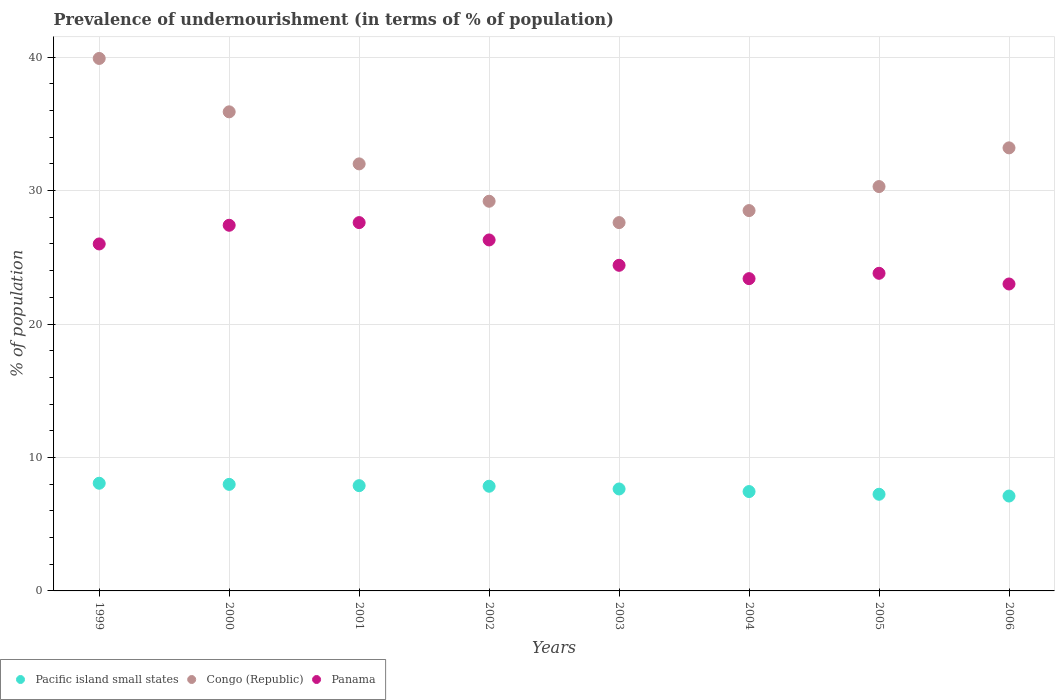How many different coloured dotlines are there?
Ensure brevity in your answer.  3. What is the percentage of undernourished population in Congo (Republic) in 2006?
Provide a short and direct response. 33.2. Across all years, what is the maximum percentage of undernourished population in Congo (Republic)?
Offer a terse response. 39.9. Across all years, what is the minimum percentage of undernourished population in Congo (Republic)?
Make the answer very short. 27.6. In which year was the percentage of undernourished population in Panama maximum?
Keep it short and to the point. 2001. What is the total percentage of undernourished population in Pacific island small states in the graph?
Keep it short and to the point. 61.22. What is the difference between the percentage of undernourished population in Panama in 2001 and that in 2002?
Keep it short and to the point. 1.3. What is the difference between the percentage of undernourished population in Congo (Republic) in 2003 and the percentage of undernourished population in Panama in 2005?
Offer a terse response. 3.8. What is the average percentage of undernourished population in Congo (Republic) per year?
Give a very brief answer. 32.08. In the year 2004, what is the difference between the percentage of undernourished population in Pacific island small states and percentage of undernourished population in Panama?
Offer a terse response. -15.95. In how many years, is the percentage of undernourished population in Pacific island small states greater than 26 %?
Provide a short and direct response. 0. What is the ratio of the percentage of undernourished population in Panama in 1999 to that in 2006?
Give a very brief answer. 1.13. What is the difference between the highest and the second highest percentage of undernourished population in Panama?
Ensure brevity in your answer.  0.2. What is the difference between the highest and the lowest percentage of undernourished population in Congo (Republic)?
Your response must be concise. 12.3. Is the percentage of undernourished population in Pacific island small states strictly greater than the percentage of undernourished population in Congo (Republic) over the years?
Provide a succinct answer. No. How many years are there in the graph?
Offer a very short reply. 8. What is the difference between two consecutive major ticks on the Y-axis?
Offer a very short reply. 10. Are the values on the major ticks of Y-axis written in scientific E-notation?
Offer a very short reply. No. Does the graph contain grids?
Provide a succinct answer. Yes. How many legend labels are there?
Provide a short and direct response. 3. What is the title of the graph?
Offer a terse response. Prevalence of undernourishment (in terms of % of population). What is the label or title of the X-axis?
Offer a terse response. Years. What is the label or title of the Y-axis?
Your answer should be compact. % of population. What is the % of population in Pacific island small states in 1999?
Your answer should be compact. 8.07. What is the % of population of Congo (Republic) in 1999?
Ensure brevity in your answer.  39.9. What is the % of population of Panama in 1999?
Offer a very short reply. 26. What is the % of population of Pacific island small states in 2000?
Keep it short and to the point. 7.98. What is the % of population in Congo (Republic) in 2000?
Provide a succinct answer. 35.9. What is the % of population of Panama in 2000?
Ensure brevity in your answer.  27.4. What is the % of population in Pacific island small states in 2001?
Provide a succinct answer. 7.89. What is the % of population in Congo (Republic) in 2001?
Ensure brevity in your answer.  32. What is the % of population in Panama in 2001?
Offer a very short reply. 27.6. What is the % of population of Pacific island small states in 2002?
Provide a succinct answer. 7.84. What is the % of population of Congo (Republic) in 2002?
Provide a succinct answer. 29.2. What is the % of population in Panama in 2002?
Your answer should be compact. 26.3. What is the % of population in Pacific island small states in 2003?
Keep it short and to the point. 7.64. What is the % of population of Congo (Republic) in 2003?
Your answer should be very brief. 27.6. What is the % of population in Panama in 2003?
Provide a short and direct response. 24.4. What is the % of population of Pacific island small states in 2004?
Your answer should be compact. 7.45. What is the % of population in Panama in 2004?
Offer a terse response. 23.4. What is the % of population in Pacific island small states in 2005?
Your answer should be compact. 7.24. What is the % of population of Congo (Republic) in 2005?
Ensure brevity in your answer.  30.3. What is the % of population in Panama in 2005?
Provide a short and direct response. 23.8. What is the % of population in Pacific island small states in 2006?
Your answer should be compact. 7.11. What is the % of population of Congo (Republic) in 2006?
Provide a short and direct response. 33.2. Across all years, what is the maximum % of population of Pacific island small states?
Provide a succinct answer. 8.07. Across all years, what is the maximum % of population in Congo (Republic)?
Your answer should be compact. 39.9. Across all years, what is the maximum % of population in Panama?
Ensure brevity in your answer.  27.6. Across all years, what is the minimum % of population in Pacific island small states?
Keep it short and to the point. 7.11. Across all years, what is the minimum % of population of Congo (Republic)?
Provide a succinct answer. 27.6. Across all years, what is the minimum % of population of Panama?
Ensure brevity in your answer.  23. What is the total % of population in Pacific island small states in the graph?
Keep it short and to the point. 61.22. What is the total % of population of Congo (Republic) in the graph?
Offer a very short reply. 256.6. What is the total % of population in Panama in the graph?
Make the answer very short. 201.9. What is the difference between the % of population of Pacific island small states in 1999 and that in 2000?
Your response must be concise. 0.08. What is the difference between the % of population in Pacific island small states in 1999 and that in 2001?
Your answer should be very brief. 0.18. What is the difference between the % of population in Panama in 1999 and that in 2001?
Provide a short and direct response. -1.6. What is the difference between the % of population of Pacific island small states in 1999 and that in 2002?
Your answer should be very brief. 0.22. What is the difference between the % of population in Pacific island small states in 1999 and that in 2003?
Keep it short and to the point. 0.43. What is the difference between the % of population in Congo (Republic) in 1999 and that in 2003?
Your answer should be very brief. 12.3. What is the difference between the % of population in Panama in 1999 and that in 2003?
Ensure brevity in your answer.  1.6. What is the difference between the % of population in Pacific island small states in 1999 and that in 2004?
Give a very brief answer. 0.62. What is the difference between the % of population of Congo (Republic) in 1999 and that in 2004?
Make the answer very short. 11.4. What is the difference between the % of population in Pacific island small states in 1999 and that in 2005?
Ensure brevity in your answer.  0.83. What is the difference between the % of population in Congo (Republic) in 1999 and that in 2005?
Provide a succinct answer. 9.6. What is the difference between the % of population of Pacific island small states in 1999 and that in 2006?
Give a very brief answer. 0.96. What is the difference between the % of population of Panama in 1999 and that in 2006?
Offer a terse response. 3. What is the difference between the % of population of Pacific island small states in 2000 and that in 2001?
Provide a short and direct response. 0.1. What is the difference between the % of population in Congo (Republic) in 2000 and that in 2001?
Offer a very short reply. 3.9. What is the difference between the % of population of Panama in 2000 and that in 2001?
Make the answer very short. -0.2. What is the difference between the % of population in Pacific island small states in 2000 and that in 2002?
Provide a short and direct response. 0.14. What is the difference between the % of population of Congo (Republic) in 2000 and that in 2002?
Keep it short and to the point. 6.7. What is the difference between the % of population of Panama in 2000 and that in 2002?
Ensure brevity in your answer.  1.1. What is the difference between the % of population in Pacific island small states in 2000 and that in 2003?
Your answer should be compact. 0.34. What is the difference between the % of population of Congo (Republic) in 2000 and that in 2003?
Make the answer very short. 8.3. What is the difference between the % of population in Pacific island small states in 2000 and that in 2004?
Your answer should be compact. 0.54. What is the difference between the % of population of Congo (Republic) in 2000 and that in 2004?
Offer a terse response. 7.4. What is the difference between the % of population in Pacific island small states in 2000 and that in 2005?
Provide a succinct answer. 0.74. What is the difference between the % of population in Panama in 2000 and that in 2005?
Your answer should be compact. 3.6. What is the difference between the % of population of Pacific island small states in 2000 and that in 2006?
Your answer should be very brief. 0.87. What is the difference between the % of population in Congo (Republic) in 2000 and that in 2006?
Provide a short and direct response. 2.7. What is the difference between the % of population in Panama in 2000 and that in 2006?
Your answer should be very brief. 4.4. What is the difference between the % of population of Pacific island small states in 2001 and that in 2002?
Provide a succinct answer. 0.04. What is the difference between the % of population of Congo (Republic) in 2001 and that in 2002?
Provide a short and direct response. 2.8. What is the difference between the % of population of Panama in 2001 and that in 2002?
Offer a very short reply. 1.3. What is the difference between the % of population in Pacific island small states in 2001 and that in 2003?
Keep it short and to the point. 0.25. What is the difference between the % of population of Panama in 2001 and that in 2003?
Offer a very short reply. 3.2. What is the difference between the % of population of Pacific island small states in 2001 and that in 2004?
Your answer should be very brief. 0.44. What is the difference between the % of population of Congo (Republic) in 2001 and that in 2004?
Provide a short and direct response. 3.5. What is the difference between the % of population in Pacific island small states in 2001 and that in 2005?
Your answer should be very brief. 0.65. What is the difference between the % of population in Congo (Republic) in 2001 and that in 2005?
Provide a succinct answer. 1.7. What is the difference between the % of population in Pacific island small states in 2001 and that in 2006?
Your answer should be compact. 0.78. What is the difference between the % of population in Panama in 2001 and that in 2006?
Make the answer very short. 4.6. What is the difference between the % of population of Pacific island small states in 2002 and that in 2003?
Provide a short and direct response. 0.2. What is the difference between the % of population in Pacific island small states in 2002 and that in 2004?
Your answer should be very brief. 0.4. What is the difference between the % of population in Congo (Republic) in 2002 and that in 2004?
Provide a short and direct response. 0.7. What is the difference between the % of population in Panama in 2002 and that in 2004?
Your response must be concise. 2.9. What is the difference between the % of population of Pacific island small states in 2002 and that in 2005?
Your response must be concise. 0.6. What is the difference between the % of population of Congo (Republic) in 2002 and that in 2005?
Your response must be concise. -1.1. What is the difference between the % of population of Panama in 2002 and that in 2005?
Give a very brief answer. 2.5. What is the difference between the % of population of Pacific island small states in 2002 and that in 2006?
Offer a terse response. 0.73. What is the difference between the % of population in Panama in 2002 and that in 2006?
Offer a terse response. 3.3. What is the difference between the % of population of Pacific island small states in 2003 and that in 2004?
Your answer should be very brief. 0.19. What is the difference between the % of population of Congo (Republic) in 2003 and that in 2004?
Keep it short and to the point. -0.9. What is the difference between the % of population of Panama in 2003 and that in 2004?
Provide a succinct answer. 1. What is the difference between the % of population in Pacific island small states in 2003 and that in 2005?
Provide a short and direct response. 0.4. What is the difference between the % of population in Congo (Republic) in 2003 and that in 2005?
Offer a terse response. -2.7. What is the difference between the % of population in Panama in 2003 and that in 2005?
Offer a very short reply. 0.6. What is the difference between the % of population of Pacific island small states in 2003 and that in 2006?
Offer a terse response. 0.53. What is the difference between the % of population in Panama in 2003 and that in 2006?
Keep it short and to the point. 1.4. What is the difference between the % of population in Pacific island small states in 2004 and that in 2005?
Offer a very short reply. 0.2. What is the difference between the % of population of Congo (Republic) in 2004 and that in 2005?
Give a very brief answer. -1.8. What is the difference between the % of population of Panama in 2004 and that in 2005?
Provide a short and direct response. -0.4. What is the difference between the % of population of Pacific island small states in 2004 and that in 2006?
Offer a terse response. 0.34. What is the difference between the % of population in Pacific island small states in 2005 and that in 2006?
Provide a short and direct response. 0.13. What is the difference between the % of population of Pacific island small states in 1999 and the % of population of Congo (Republic) in 2000?
Make the answer very short. -27.83. What is the difference between the % of population in Pacific island small states in 1999 and the % of population in Panama in 2000?
Offer a terse response. -19.33. What is the difference between the % of population in Pacific island small states in 1999 and the % of population in Congo (Republic) in 2001?
Your response must be concise. -23.93. What is the difference between the % of population in Pacific island small states in 1999 and the % of population in Panama in 2001?
Keep it short and to the point. -19.53. What is the difference between the % of population in Congo (Republic) in 1999 and the % of population in Panama in 2001?
Your answer should be compact. 12.3. What is the difference between the % of population of Pacific island small states in 1999 and the % of population of Congo (Republic) in 2002?
Give a very brief answer. -21.13. What is the difference between the % of population of Pacific island small states in 1999 and the % of population of Panama in 2002?
Provide a short and direct response. -18.23. What is the difference between the % of population of Pacific island small states in 1999 and the % of population of Congo (Republic) in 2003?
Give a very brief answer. -19.53. What is the difference between the % of population of Pacific island small states in 1999 and the % of population of Panama in 2003?
Your answer should be very brief. -16.33. What is the difference between the % of population in Pacific island small states in 1999 and the % of population in Congo (Republic) in 2004?
Ensure brevity in your answer.  -20.43. What is the difference between the % of population of Pacific island small states in 1999 and the % of population of Panama in 2004?
Your response must be concise. -15.33. What is the difference between the % of population of Congo (Republic) in 1999 and the % of population of Panama in 2004?
Your response must be concise. 16.5. What is the difference between the % of population of Pacific island small states in 1999 and the % of population of Congo (Republic) in 2005?
Provide a succinct answer. -22.23. What is the difference between the % of population of Pacific island small states in 1999 and the % of population of Panama in 2005?
Keep it short and to the point. -15.73. What is the difference between the % of population of Pacific island small states in 1999 and the % of population of Congo (Republic) in 2006?
Ensure brevity in your answer.  -25.13. What is the difference between the % of population in Pacific island small states in 1999 and the % of population in Panama in 2006?
Keep it short and to the point. -14.93. What is the difference between the % of population in Pacific island small states in 2000 and the % of population in Congo (Republic) in 2001?
Make the answer very short. -24.02. What is the difference between the % of population in Pacific island small states in 2000 and the % of population in Panama in 2001?
Offer a terse response. -19.62. What is the difference between the % of population in Congo (Republic) in 2000 and the % of population in Panama in 2001?
Ensure brevity in your answer.  8.3. What is the difference between the % of population in Pacific island small states in 2000 and the % of population in Congo (Republic) in 2002?
Offer a very short reply. -21.22. What is the difference between the % of population of Pacific island small states in 2000 and the % of population of Panama in 2002?
Make the answer very short. -18.32. What is the difference between the % of population in Congo (Republic) in 2000 and the % of population in Panama in 2002?
Give a very brief answer. 9.6. What is the difference between the % of population in Pacific island small states in 2000 and the % of population in Congo (Republic) in 2003?
Provide a succinct answer. -19.62. What is the difference between the % of population in Pacific island small states in 2000 and the % of population in Panama in 2003?
Make the answer very short. -16.42. What is the difference between the % of population of Pacific island small states in 2000 and the % of population of Congo (Republic) in 2004?
Give a very brief answer. -20.52. What is the difference between the % of population of Pacific island small states in 2000 and the % of population of Panama in 2004?
Your answer should be compact. -15.42. What is the difference between the % of population in Pacific island small states in 2000 and the % of population in Congo (Republic) in 2005?
Give a very brief answer. -22.32. What is the difference between the % of population in Pacific island small states in 2000 and the % of population in Panama in 2005?
Give a very brief answer. -15.82. What is the difference between the % of population in Pacific island small states in 2000 and the % of population in Congo (Republic) in 2006?
Provide a succinct answer. -25.22. What is the difference between the % of population of Pacific island small states in 2000 and the % of population of Panama in 2006?
Offer a very short reply. -15.02. What is the difference between the % of population in Pacific island small states in 2001 and the % of population in Congo (Republic) in 2002?
Provide a short and direct response. -21.31. What is the difference between the % of population of Pacific island small states in 2001 and the % of population of Panama in 2002?
Keep it short and to the point. -18.41. What is the difference between the % of population of Pacific island small states in 2001 and the % of population of Congo (Republic) in 2003?
Your answer should be very brief. -19.71. What is the difference between the % of population of Pacific island small states in 2001 and the % of population of Panama in 2003?
Offer a very short reply. -16.51. What is the difference between the % of population in Congo (Republic) in 2001 and the % of population in Panama in 2003?
Your answer should be compact. 7.6. What is the difference between the % of population in Pacific island small states in 2001 and the % of population in Congo (Republic) in 2004?
Your response must be concise. -20.61. What is the difference between the % of population of Pacific island small states in 2001 and the % of population of Panama in 2004?
Your answer should be compact. -15.51. What is the difference between the % of population in Pacific island small states in 2001 and the % of population in Congo (Republic) in 2005?
Offer a terse response. -22.41. What is the difference between the % of population in Pacific island small states in 2001 and the % of population in Panama in 2005?
Your answer should be very brief. -15.91. What is the difference between the % of population in Congo (Republic) in 2001 and the % of population in Panama in 2005?
Keep it short and to the point. 8.2. What is the difference between the % of population in Pacific island small states in 2001 and the % of population in Congo (Republic) in 2006?
Your answer should be very brief. -25.31. What is the difference between the % of population in Pacific island small states in 2001 and the % of population in Panama in 2006?
Give a very brief answer. -15.11. What is the difference between the % of population in Congo (Republic) in 2001 and the % of population in Panama in 2006?
Make the answer very short. 9. What is the difference between the % of population of Pacific island small states in 2002 and the % of population of Congo (Republic) in 2003?
Your response must be concise. -19.76. What is the difference between the % of population in Pacific island small states in 2002 and the % of population in Panama in 2003?
Ensure brevity in your answer.  -16.56. What is the difference between the % of population in Pacific island small states in 2002 and the % of population in Congo (Republic) in 2004?
Make the answer very short. -20.66. What is the difference between the % of population of Pacific island small states in 2002 and the % of population of Panama in 2004?
Provide a short and direct response. -15.56. What is the difference between the % of population of Pacific island small states in 2002 and the % of population of Congo (Republic) in 2005?
Provide a succinct answer. -22.46. What is the difference between the % of population of Pacific island small states in 2002 and the % of population of Panama in 2005?
Provide a succinct answer. -15.96. What is the difference between the % of population in Pacific island small states in 2002 and the % of population in Congo (Republic) in 2006?
Keep it short and to the point. -25.36. What is the difference between the % of population in Pacific island small states in 2002 and the % of population in Panama in 2006?
Provide a short and direct response. -15.16. What is the difference between the % of population in Pacific island small states in 2003 and the % of population in Congo (Republic) in 2004?
Provide a short and direct response. -20.86. What is the difference between the % of population in Pacific island small states in 2003 and the % of population in Panama in 2004?
Keep it short and to the point. -15.76. What is the difference between the % of population of Congo (Republic) in 2003 and the % of population of Panama in 2004?
Your answer should be compact. 4.2. What is the difference between the % of population in Pacific island small states in 2003 and the % of population in Congo (Republic) in 2005?
Provide a succinct answer. -22.66. What is the difference between the % of population of Pacific island small states in 2003 and the % of population of Panama in 2005?
Offer a very short reply. -16.16. What is the difference between the % of population of Pacific island small states in 2003 and the % of population of Congo (Republic) in 2006?
Keep it short and to the point. -25.56. What is the difference between the % of population of Pacific island small states in 2003 and the % of population of Panama in 2006?
Your answer should be very brief. -15.36. What is the difference between the % of population in Congo (Republic) in 2003 and the % of population in Panama in 2006?
Offer a very short reply. 4.6. What is the difference between the % of population in Pacific island small states in 2004 and the % of population in Congo (Republic) in 2005?
Your answer should be compact. -22.85. What is the difference between the % of population in Pacific island small states in 2004 and the % of population in Panama in 2005?
Your answer should be compact. -16.35. What is the difference between the % of population in Congo (Republic) in 2004 and the % of population in Panama in 2005?
Your answer should be very brief. 4.7. What is the difference between the % of population in Pacific island small states in 2004 and the % of population in Congo (Republic) in 2006?
Provide a succinct answer. -25.75. What is the difference between the % of population in Pacific island small states in 2004 and the % of population in Panama in 2006?
Give a very brief answer. -15.55. What is the difference between the % of population in Pacific island small states in 2005 and the % of population in Congo (Republic) in 2006?
Provide a short and direct response. -25.96. What is the difference between the % of population of Pacific island small states in 2005 and the % of population of Panama in 2006?
Your response must be concise. -15.76. What is the difference between the % of population of Congo (Republic) in 2005 and the % of population of Panama in 2006?
Keep it short and to the point. 7.3. What is the average % of population of Pacific island small states per year?
Offer a very short reply. 7.65. What is the average % of population in Congo (Republic) per year?
Keep it short and to the point. 32.08. What is the average % of population of Panama per year?
Ensure brevity in your answer.  25.24. In the year 1999, what is the difference between the % of population in Pacific island small states and % of population in Congo (Republic)?
Your response must be concise. -31.83. In the year 1999, what is the difference between the % of population of Pacific island small states and % of population of Panama?
Provide a succinct answer. -17.93. In the year 1999, what is the difference between the % of population in Congo (Republic) and % of population in Panama?
Keep it short and to the point. 13.9. In the year 2000, what is the difference between the % of population in Pacific island small states and % of population in Congo (Republic)?
Make the answer very short. -27.92. In the year 2000, what is the difference between the % of population of Pacific island small states and % of population of Panama?
Your answer should be compact. -19.42. In the year 2001, what is the difference between the % of population in Pacific island small states and % of population in Congo (Republic)?
Your response must be concise. -24.11. In the year 2001, what is the difference between the % of population of Pacific island small states and % of population of Panama?
Keep it short and to the point. -19.71. In the year 2002, what is the difference between the % of population of Pacific island small states and % of population of Congo (Republic)?
Ensure brevity in your answer.  -21.36. In the year 2002, what is the difference between the % of population of Pacific island small states and % of population of Panama?
Offer a very short reply. -18.46. In the year 2002, what is the difference between the % of population in Congo (Republic) and % of population in Panama?
Your answer should be very brief. 2.9. In the year 2003, what is the difference between the % of population in Pacific island small states and % of population in Congo (Republic)?
Ensure brevity in your answer.  -19.96. In the year 2003, what is the difference between the % of population in Pacific island small states and % of population in Panama?
Offer a terse response. -16.76. In the year 2004, what is the difference between the % of population of Pacific island small states and % of population of Congo (Republic)?
Ensure brevity in your answer.  -21.05. In the year 2004, what is the difference between the % of population of Pacific island small states and % of population of Panama?
Make the answer very short. -15.95. In the year 2005, what is the difference between the % of population of Pacific island small states and % of population of Congo (Republic)?
Provide a short and direct response. -23.06. In the year 2005, what is the difference between the % of population of Pacific island small states and % of population of Panama?
Give a very brief answer. -16.56. In the year 2005, what is the difference between the % of population of Congo (Republic) and % of population of Panama?
Keep it short and to the point. 6.5. In the year 2006, what is the difference between the % of population of Pacific island small states and % of population of Congo (Republic)?
Your answer should be very brief. -26.09. In the year 2006, what is the difference between the % of population of Pacific island small states and % of population of Panama?
Make the answer very short. -15.89. In the year 2006, what is the difference between the % of population in Congo (Republic) and % of population in Panama?
Offer a very short reply. 10.2. What is the ratio of the % of population of Pacific island small states in 1999 to that in 2000?
Your answer should be compact. 1.01. What is the ratio of the % of population of Congo (Republic) in 1999 to that in 2000?
Ensure brevity in your answer.  1.11. What is the ratio of the % of population of Panama in 1999 to that in 2000?
Offer a terse response. 0.95. What is the ratio of the % of population in Pacific island small states in 1999 to that in 2001?
Offer a very short reply. 1.02. What is the ratio of the % of population in Congo (Republic) in 1999 to that in 2001?
Give a very brief answer. 1.25. What is the ratio of the % of population of Panama in 1999 to that in 2001?
Offer a terse response. 0.94. What is the ratio of the % of population of Pacific island small states in 1999 to that in 2002?
Give a very brief answer. 1.03. What is the ratio of the % of population of Congo (Republic) in 1999 to that in 2002?
Your answer should be very brief. 1.37. What is the ratio of the % of population in Pacific island small states in 1999 to that in 2003?
Offer a terse response. 1.06. What is the ratio of the % of population in Congo (Republic) in 1999 to that in 2003?
Keep it short and to the point. 1.45. What is the ratio of the % of population of Panama in 1999 to that in 2003?
Provide a succinct answer. 1.07. What is the ratio of the % of population of Pacific island small states in 1999 to that in 2004?
Offer a terse response. 1.08. What is the ratio of the % of population in Pacific island small states in 1999 to that in 2005?
Provide a succinct answer. 1.11. What is the ratio of the % of population of Congo (Republic) in 1999 to that in 2005?
Offer a terse response. 1.32. What is the ratio of the % of population in Panama in 1999 to that in 2005?
Offer a terse response. 1.09. What is the ratio of the % of population in Pacific island small states in 1999 to that in 2006?
Your answer should be very brief. 1.13. What is the ratio of the % of population in Congo (Republic) in 1999 to that in 2006?
Give a very brief answer. 1.2. What is the ratio of the % of population in Panama in 1999 to that in 2006?
Your response must be concise. 1.13. What is the ratio of the % of population of Pacific island small states in 2000 to that in 2001?
Your response must be concise. 1.01. What is the ratio of the % of population of Congo (Republic) in 2000 to that in 2001?
Your answer should be compact. 1.12. What is the ratio of the % of population in Panama in 2000 to that in 2001?
Keep it short and to the point. 0.99. What is the ratio of the % of population in Pacific island small states in 2000 to that in 2002?
Provide a short and direct response. 1.02. What is the ratio of the % of population in Congo (Republic) in 2000 to that in 2002?
Offer a very short reply. 1.23. What is the ratio of the % of population in Panama in 2000 to that in 2002?
Make the answer very short. 1.04. What is the ratio of the % of population of Pacific island small states in 2000 to that in 2003?
Provide a succinct answer. 1.04. What is the ratio of the % of population in Congo (Republic) in 2000 to that in 2003?
Provide a succinct answer. 1.3. What is the ratio of the % of population of Panama in 2000 to that in 2003?
Offer a very short reply. 1.12. What is the ratio of the % of population of Pacific island small states in 2000 to that in 2004?
Ensure brevity in your answer.  1.07. What is the ratio of the % of population in Congo (Republic) in 2000 to that in 2004?
Your answer should be compact. 1.26. What is the ratio of the % of population in Panama in 2000 to that in 2004?
Ensure brevity in your answer.  1.17. What is the ratio of the % of population in Pacific island small states in 2000 to that in 2005?
Your response must be concise. 1.1. What is the ratio of the % of population of Congo (Republic) in 2000 to that in 2005?
Make the answer very short. 1.18. What is the ratio of the % of population of Panama in 2000 to that in 2005?
Give a very brief answer. 1.15. What is the ratio of the % of population in Pacific island small states in 2000 to that in 2006?
Your answer should be compact. 1.12. What is the ratio of the % of population in Congo (Republic) in 2000 to that in 2006?
Provide a short and direct response. 1.08. What is the ratio of the % of population of Panama in 2000 to that in 2006?
Give a very brief answer. 1.19. What is the ratio of the % of population of Pacific island small states in 2001 to that in 2002?
Provide a succinct answer. 1.01. What is the ratio of the % of population of Congo (Republic) in 2001 to that in 2002?
Give a very brief answer. 1.1. What is the ratio of the % of population of Panama in 2001 to that in 2002?
Ensure brevity in your answer.  1.05. What is the ratio of the % of population in Pacific island small states in 2001 to that in 2003?
Keep it short and to the point. 1.03. What is the ratio of the % of population in Congo (Republic) in 2001 to that in 2003?
Provide a short and direct response. 1.16. What is the ratio of the % of population of Panama in 2001 to that in 2003?
Ensure brevity in your answer.  1.13. What is the ratio of the % of population in Pacific island small states in 2001 to that in 2004?
Keep it short and to the point. 1.06. What is the ratio of the % of population in Congo (Republic) in 2001 to that in 2004?
Provide a short and direct response. 1.12. What is the ratio of the % of population of Panama in 2001 to that in 2004?
Provide a succinct answer. 1.18. What is the ratio of the % of population in Pacific island small states in 2001 to that in 2005?
Offer a terse response. 1.09. What is the ratio of the % of population of Congo (Republic) in 2001 to that in 2005?
Your answer should be compact. 1.06. What is the ratio of the % of population in Panama in 2001 to that in 2005?
Your answer should be compact. 1.16. What is the ratio of the % of population of Pacific island small states in 2001 to that in 2006?
Keep it short and to the point. 1.11. What is the ratio of the % of population in Congo (Republic) in 2001 to that in 2006?
Your response must be concise. 0.96. What is the ratio of the % of population of Pacific island small states in 2002 to that in 2003?
Your answer should be compact. 1.03. What is the ratio of the % of population in Congo (Republic) in 2002 to that in 2003?
Provide a succinct answer. 1.06. What is the ratio of the % of population of Panama in 2002 to that in 2003?
Ensure brevity in your answer.  1.08. What is the ratio of the % of population of Pacific island small states in 2002 to that in 2004?
Offer a terse response. 1.05. What is the ratio of the % of population of Congo (Republic) in 2002 to that in 2004?
Give a very brief answer. 1.02. What is the ratio of the % of population in Panama in 2002 to that in 2004?
Offer a terse response. 1.12. What is the ratio of the % of population in Pacific island small states in 2002 to that in 2005?
Give a very brief answer. 1.08. What is the ratio of the % of population of Congo (Republic) in 2002 to that in 2005?
Your answer should be very brief. 0.96. What is the ratio of the % of population in Panama in 2002 to that in 2005?
Offer a terse response. 1.1. What is the ratio of the % of population in Pacific island small states in 2002 to that in 2006?
Provide a short and direct response. 1.1. What is the ratio of the % of population of Congo (Republic) in 2002 to that in 2006?
Provide a succinct answer. 0.88. What is the ratio of the % of population in Panama in 2002 to that in 2006?
Provide a short and direct response. 1.14. What is the ratio of the % of population in Pacific island small states in 2003 to that in 2004?
Your answer should be compact. 1.03. What is the ratio of the % of population of Congo (Republic) in 2003 to that in 2004?
Keep it short and to the point. 0.97. What is the ratio of the % of population of Panama in 2003 to that in 2004?
Provide a short and direct response. 1.04. What is the ratio of the % of population of Pacific island small states in 2003 to that in 2005?
Offer a terse response. 1.05. What is the ratio of the % of population of Congo (Republic) in 2003 to that in 2005?
Offer a very short reply. 0.91. What is the ratio of the % of population in Panama in 2003 to that in 2005?
Provide a short and direct response. 1.03. What is the ratio of the % of population in Pacific island small states in 2003 to that in 2006?
Make the answer very short. 1.07. What is the ratio of the % of population in Congo (Republic) in 2003 to that in 2006?
Give a very brief answer. 0.83. What is the ratio of the % of population in Panama in 2003 to that in 2006?
Your answer should be compact. 1.06. What is the ratio of the % of population in Pacific island small states in 2004 to that in 2005?
Ensure brevity in your answer.  1.03. What is the ratio of the % of population of Congo (Republic) in 2004 to that in 2005?
Your answer should be very brief. 0.94. What is the ratio of the % of population of Panama in 2004 to that in 2005?
Ensure brevity in your answer.  0.98. What is the ratio of the % of population of Pacific island small states in 2004 to that in 2006?
Make the answer very short. 1.05. What is the ratio of the % of population of Congo (Republic) in 2004 to that in 2006?
Your answer should be compact. 0.86. What is the ratio of the % of population in Panama in 2004 to that in 2006?
Offer a very short reply. 1.02. What is the ratio of the % of population in Pacific island small states in 2005 to that in 2006?
Make the answer very short. 1.02. What is the ratio of the % of population in Congo (Republic) in 2005 to that in 2006?
Give a very brief answer. 0.91. What is the ratio of the % of population of Panama in 2005 to that in 2006?
Your answer should be very brief. 1.03. What is the difference between the highest and the second highest % of population of Pacific island small states?
Give a very brief answer. 0.08. What is the difference between the highest and the lowest % of population of Pacific island small states?
Your response must be concise. 0.96. What is the difference between the highest and the lowest % of population of Panama?
Your answer should be compact. 4.6. 